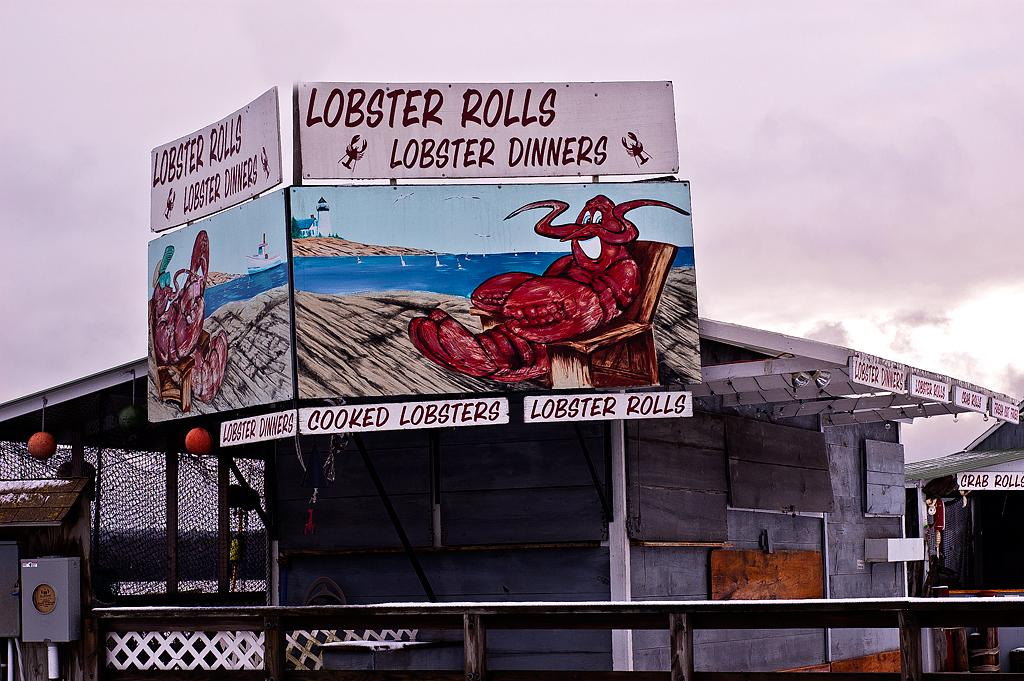<image>
Provide a brief description of the given image. A boarded up restaurant previously offered lobster rolls, lobster dinners, cooked lobsters, and more. 